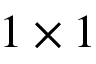Convert formula to latex. <formula><loc_0><loc_0><loc_500><loc_500>1 \times 1</formula> 